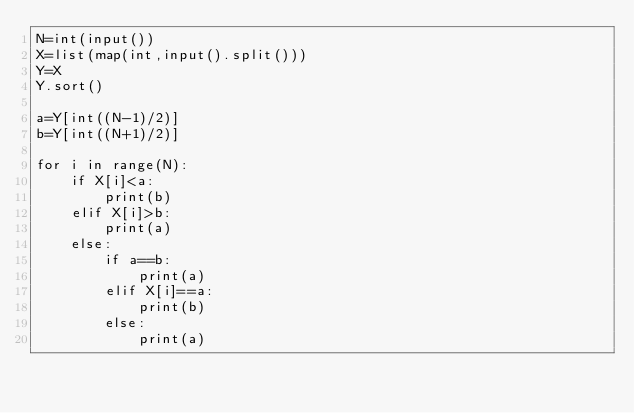Convert code to text. <code><loc_0><loc_0><loc_500><loc_500><_Python_>N=int(input())
X=list(map(int,input().split()))
Y=X
Y.sort()

a=Y[int((N-1)/2)]
b=Y[int((N+1)/2)]

for i in range(N):
    if X[i]<a:
        print(b)
    elif X[i]>b:
        print(a)
    else:
        if a==b:
            print(a)
        elif X[i]==a:
            print(b)
        else:
            print(a)
</code> 